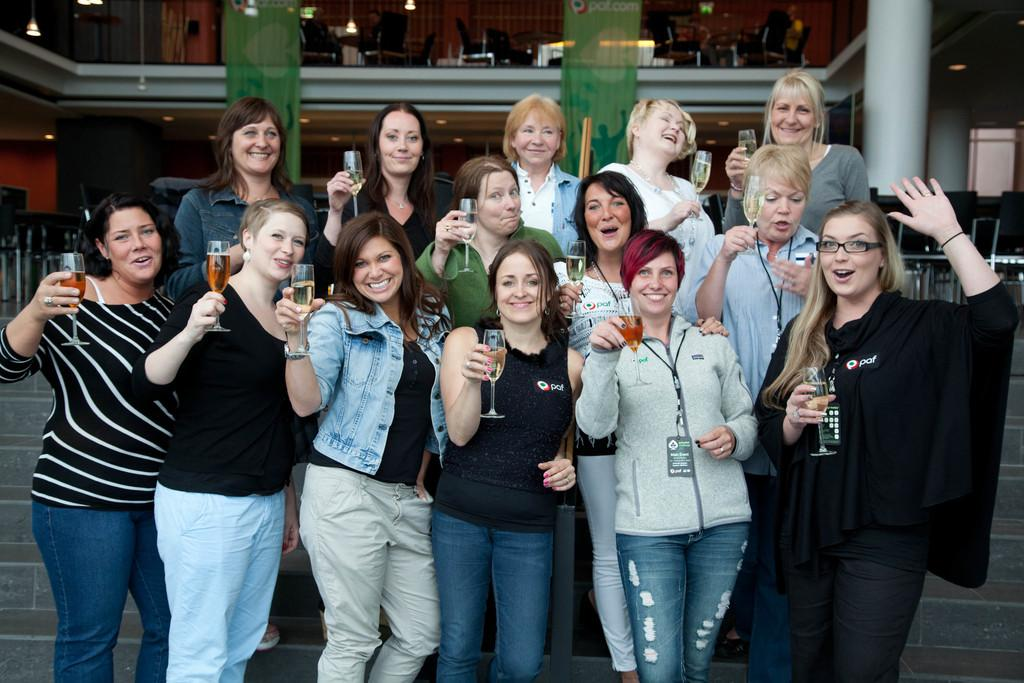What are the people in the image doing? The people in the image are standing and holding glasses. What can be seen on the posters in the background? The posters in the background are green in color. What is the color and location of the pillar in the image? There is a white color pillar on the right side of the image. What type of juice is being served in the glasses held by the people in the image? The provided facts do not mention any juice being served in the glasses. The contents of the glasses are not specified. How many brothers are present in the image? There is no mention of any brothers in the image. The people in the image are not described as being related. 